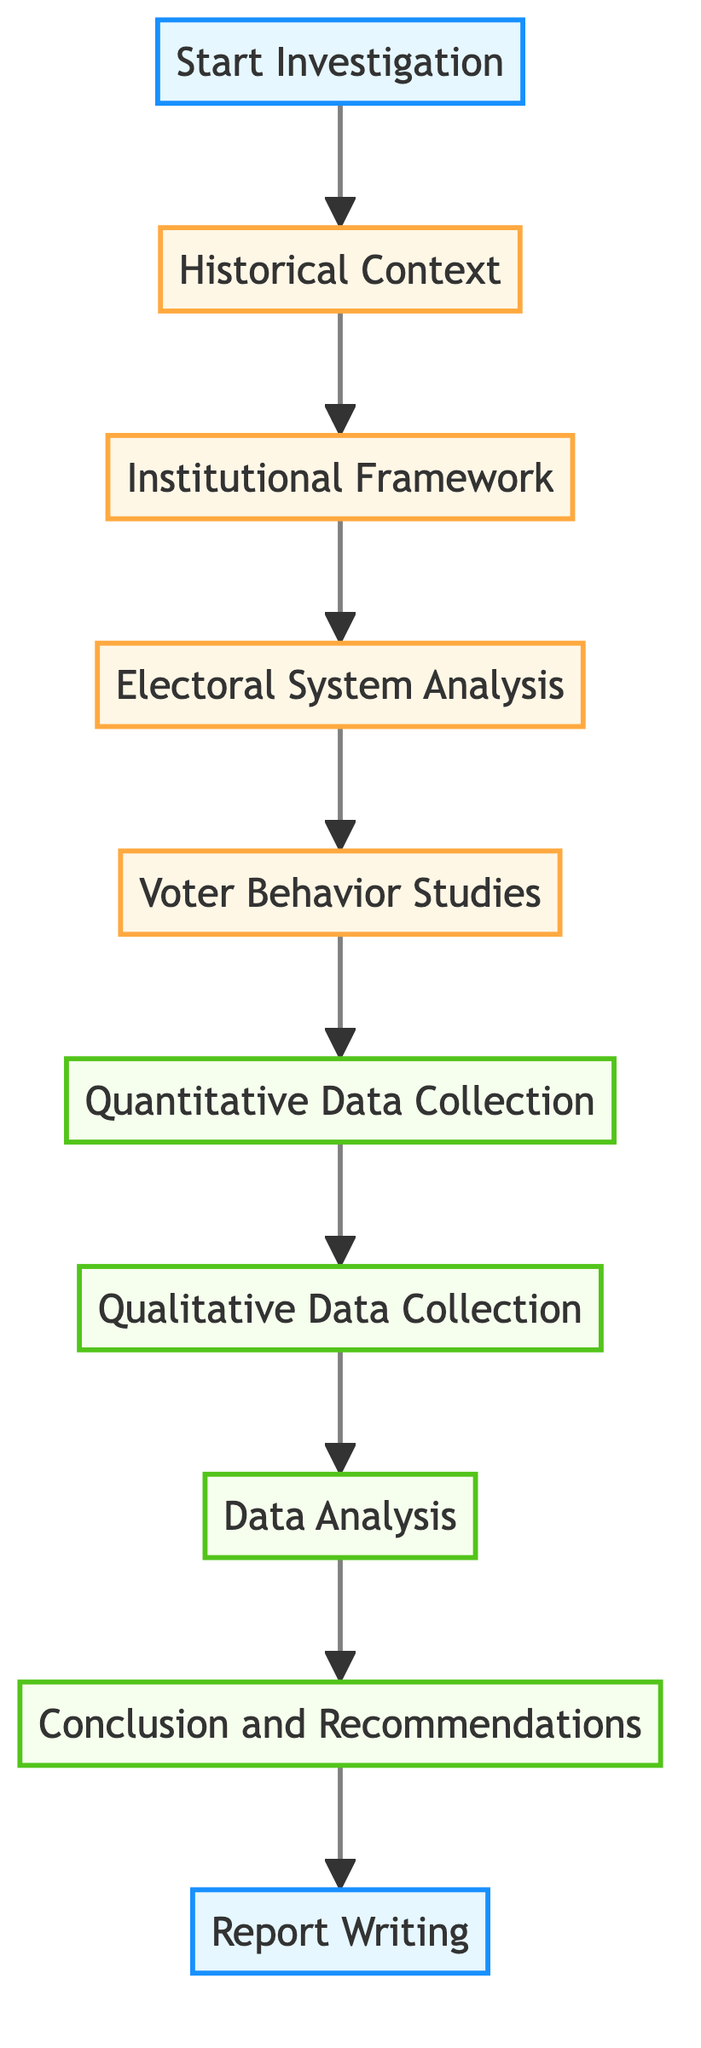What is the first step in the analysis? The first step in the diagram is labeled as "Start Investigation," indicating the initiation of the analytical process.
Answer: Start Investigation How many total steps are in the process? The diagram lists ten distinct steps from "Start Investigation" to "Report Writing." Counting these steps gives the total.
Answer: Ten What is the last step in the process? The last step listed in the diagram is "Report Writing," which follows the conclusion and recommendations.
Answer: Report Writing Which step involves collecting qualitative data? The step that involves collecting qualitative data is "Qualitative Data Collection," which is explicitly mentioned in the flow.
Answer: Qualitative Data Collection What is the relationship between "Data Analysis" and "Final Report Writing"? "Data Analysis" leads directly to "Conclusion and Recommendations," which in turn leads to "Report Writing," indicating a sequential relationship.
Answer: Sequential relationship What step focuses on analyzing the electoral system? The step dedicated to analyzing the electoral system is "Electoral System Analysis," which is clearly delineated in the flowchart.
Answer: Electoral System Analysis Which step is categorized as level 3 in the diagram? The steps "Quantitative Data Collection," "Qualitative Data Collection," and "Data Analysis" are categorized as level 3, indicating their emphasis on data collection and analysis.
Answer: Quantitative Data Collection, Qualitative Data Collection, Data Analysis Which steps are directly involved in understanding voter behavior? The steps "Voter Behavior Studies" and "Data Analysis" focus directly on understanding voter behavior, highlighting both study and analytical phases.
Answer: Voter Behavior Studies, Data Analysis At what point is the conclusion drawn? The conclusion is drawn at the step named "Conclusion and Recommendations," which comes after "Data Analysis" in the flowchart.
Answer: Conclusion and Recommendations 